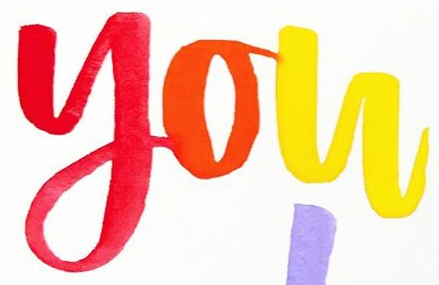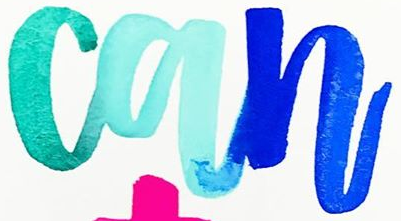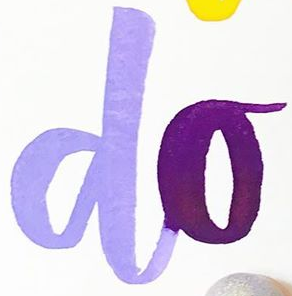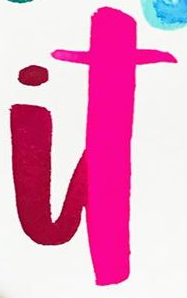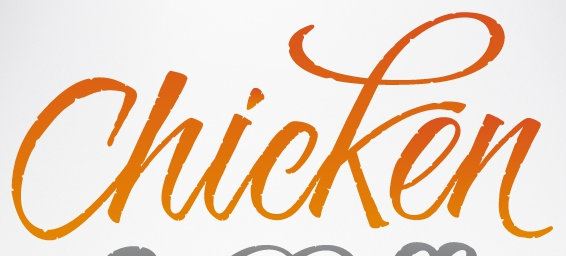What text appears in these images from left to right, separated by a semicolon? you; can; do; it; Chicken 